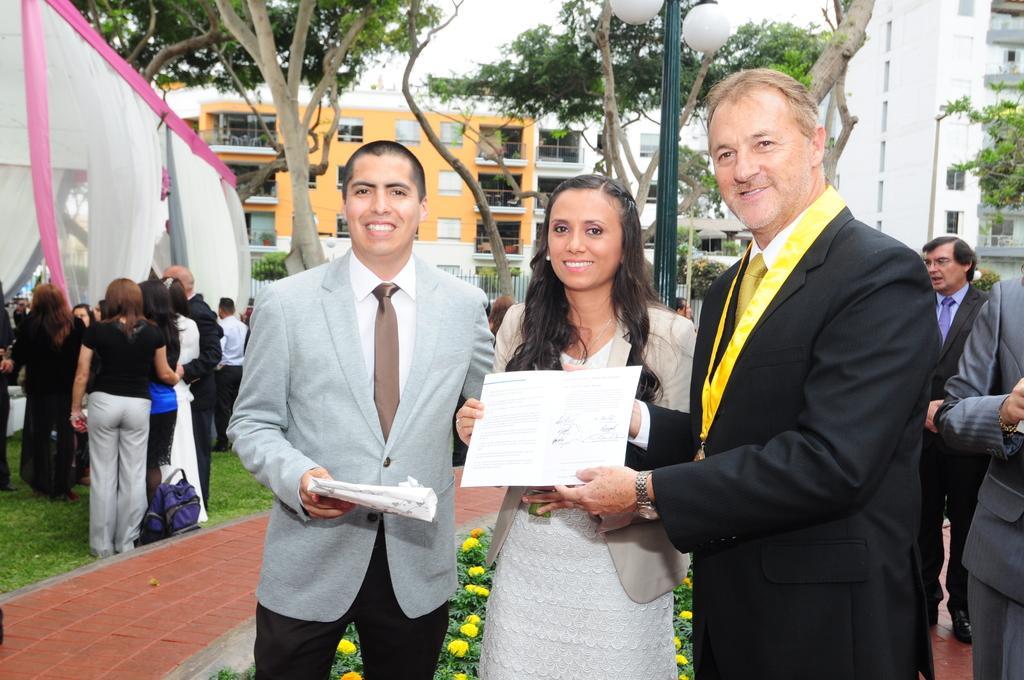Describe this image in one or two sentences. In this image we can see people standing and holding an object, we can see the flowers and leaves, on the left we can see the curtains, near that we can see trees, grass, after that we can see the fence, we can see the buildings in the background, at the top we can see the sky. 